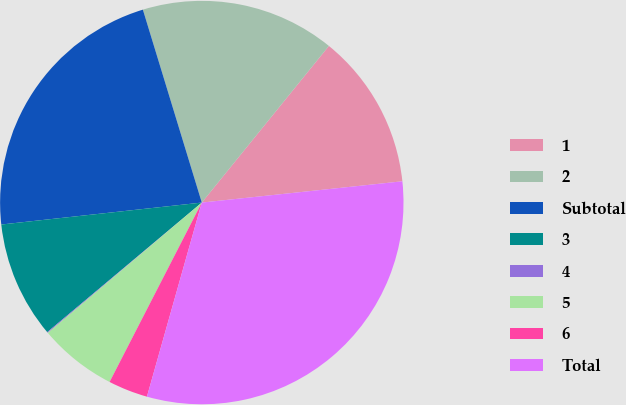Convert chart. <chart><loc_0><loc_0><loc_500><loc_500><pie_chart><fcel>1<fcel>2<fcel>Subtotal<fcel>3<fcel>4<fcel>5<fcel>6<fcel>Total<nl><fcel>12.47%<fcel>15.57%<fcel>22.02%<fcel>9.37%<fcel>0.07%<fcel>6.27%<fcel>3.17%<fcel>31.07%<nl></chart> 